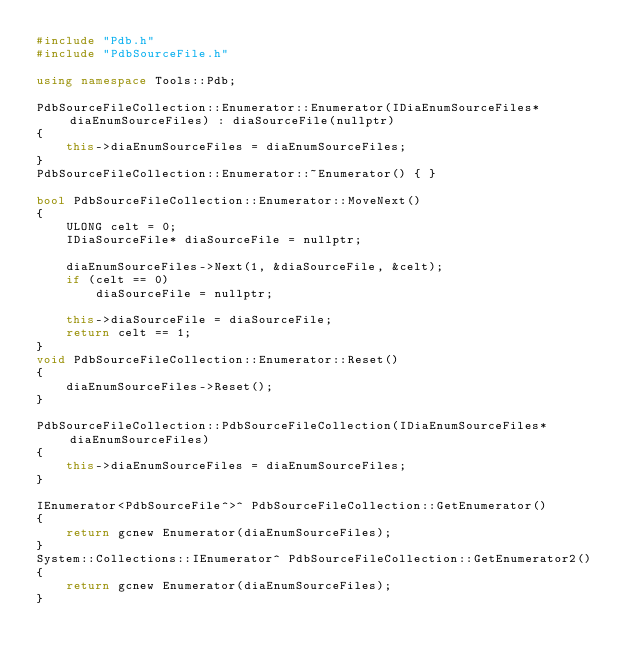<code> <loc_0><loc_0><loc_500><loc_500><_C++_>#include "Pdb.h"
#include "PdbSourceFile.h"

using namespace Tools::Pdb;

PdbSourceFileCollection::Enumerator::Enumerator(IDiaEnumSourceFiles* diaEnumSourceFiles) : diaSourceFile(nullptr)
{
    this->diaEnumSourceFiles = diaEnumSourceFiles;
}
PdbSourceFileCollection::Enumerator::~Enumerator() { }

bool PdbSourceFileCollection::Enumerator::MoveNext()
{
    ULONG celt = 0;
    IDiaSourceFile* diaSourceFile = nullptr;

    diaEnumSourceFiles->Next(1, &diaSourceFile, &celt);
    if (celt == 0)
        diaSourceFile = nullptr;

    this->diaSourceFile = diaSourceFile;
    return celt == 1;
}
void PdbSourceFileCollection::Enumerator::Reset()
{
    diaEnumSourceFiles->Reset();
}

PdbSourceFileCollection::PdbSourceFileCollection(IDiaEnumSourceFiles* diaEnumSourceFiles)
{
    this->diaEnumSourceFiles = diaEnumSourceFiles;
}

IEnumerator<PdbSourceFile^>^ PdbSourceFileCollection::GetEnumerator()
{
    return gcnew Enumerator(diaEnumSourceFiles);
}
System::Collections::IEnumerator^ PdbSourceFileCollection::GetEnumerator2()
{
    return gcnew Enumerator(diaEnumSourceFiles);
}</code> 